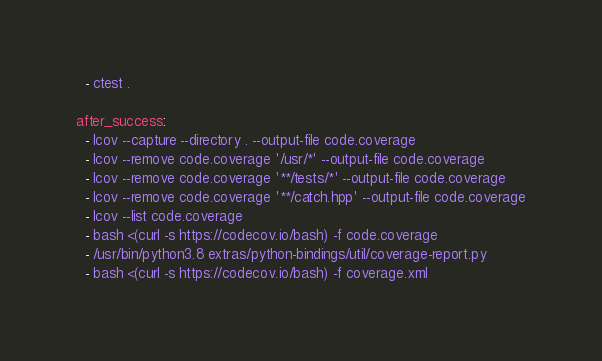<code> <loc_0><loc_0><loc_500><loc_500><_YAML_>  - ctest .

after_success:
  - lcov --capture --directory . --output-file code.coverage
  - lcov --remove code.coverage '/usr/*' --output-file code.coverage
  - lcov --remove code.coverage '**/tests/*' --output-file code.coverage
  - lcov --remove code.coverage '**/catch.hpp' --output-file code.coverage
  - lcov --list code.coverage
  - bash <(curl -s https://codecov.io/bash) -f code.coverage
  - /usr/bin/python3.8 extras/python-bindings/util/coverage-report.py
  - bash <(curl -s https://codecov.io/bash) -f coverage.xml
</code> 